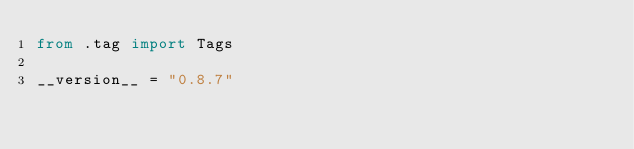Convert code to text. <code><loc_0><loc_0><loc_500><loc_500><_Python_>from .tag import Tags

__version__ = "0.8.7"
</code> 